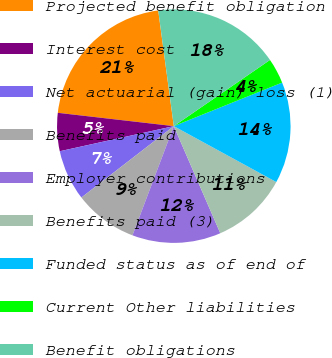<chart> <loc_0><loc_0><loc_500><loc_500><pie_chart><fcel>Projected benefit obligation<fcel>Interest cost<fcel>Net actuarial (gain) loss (1)<fcel>Benefits paid<fcel>Employer contributions<fcel>Benefits paid (3)<fcel>Funded status as of end of<fcel>Current Other liabilities<fcel>Benefit obligations<nl><fcel>21.05%<fcel>5.27%<fcel>7.02%<fcel>8.77%<fcel>12.28%<fcel>10.53%<fcel>14.03%<fcel>3.51%<fcel>17.54%<nl></chart> 